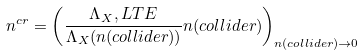Convert formula to latex. <formula><loc_0><loc_0><loc_500><loc_500>n ^ { c r } = \left ( \frac { \Lambda _ { X } , L T E } { \Lambda _ { X } ( n ( c o l l i d e r ) ) } n ( c o l l i d e r ) \right ) _ { n ( c o l l i d e r ) \rightarrow 0 }</formula> 